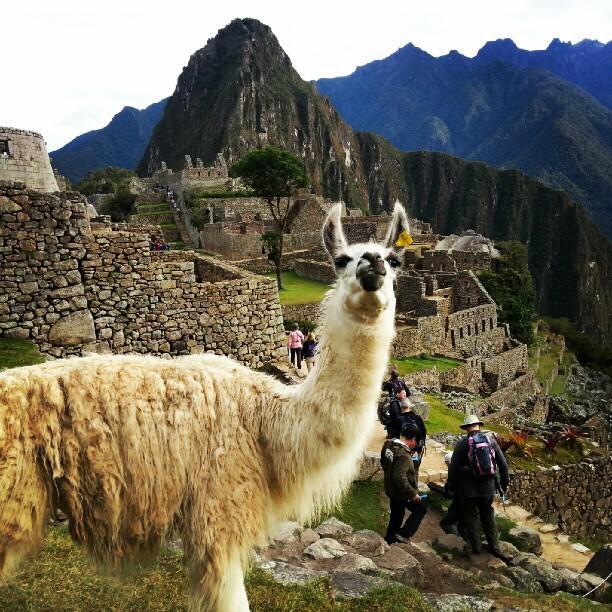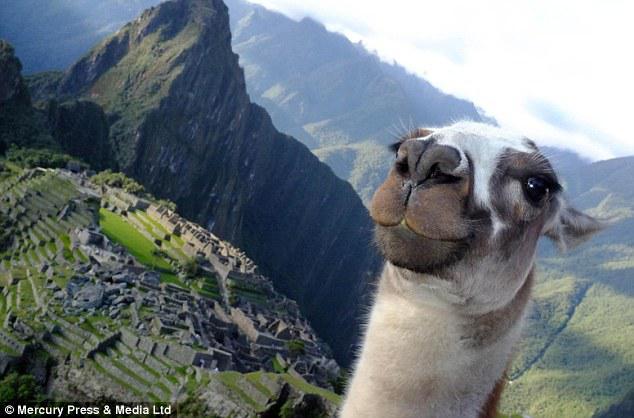The first image is the image on the left, the second image is the image on the right. Assess this claim about the two images: "The left image features a llama with head angled forward, standing in the foreground on the left, with mountains and mazelike structures behind it.". Correct or not? Answer yes or no. Yes. The first image is the image on the left, the second image is the image on the right. Considering the images on both sides, is "In at least one image there is a single white and brown lama with their neck extended and a green hill and one stone mountain peak to the right of them." valid? Answer yes or no. Yes. 